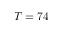<formula> <loc_0><loc_0><loc_500><loc_500>T = 7 4</formula> 